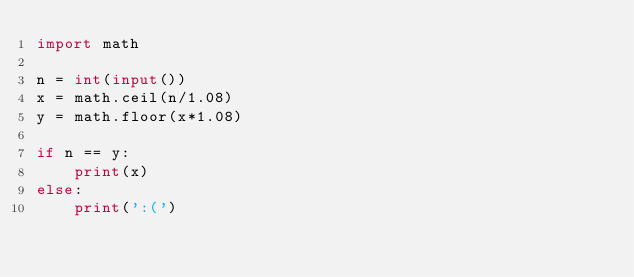Convert code to text. <code><loc_0><loc_0><loc_500><loc_500><_Python_>import math

n = int(input())
x = math.ceil(n/1.08)
y = math.floor(x*1.08)

if n == y:
    print(x)
else:
    print(':(')</code> 